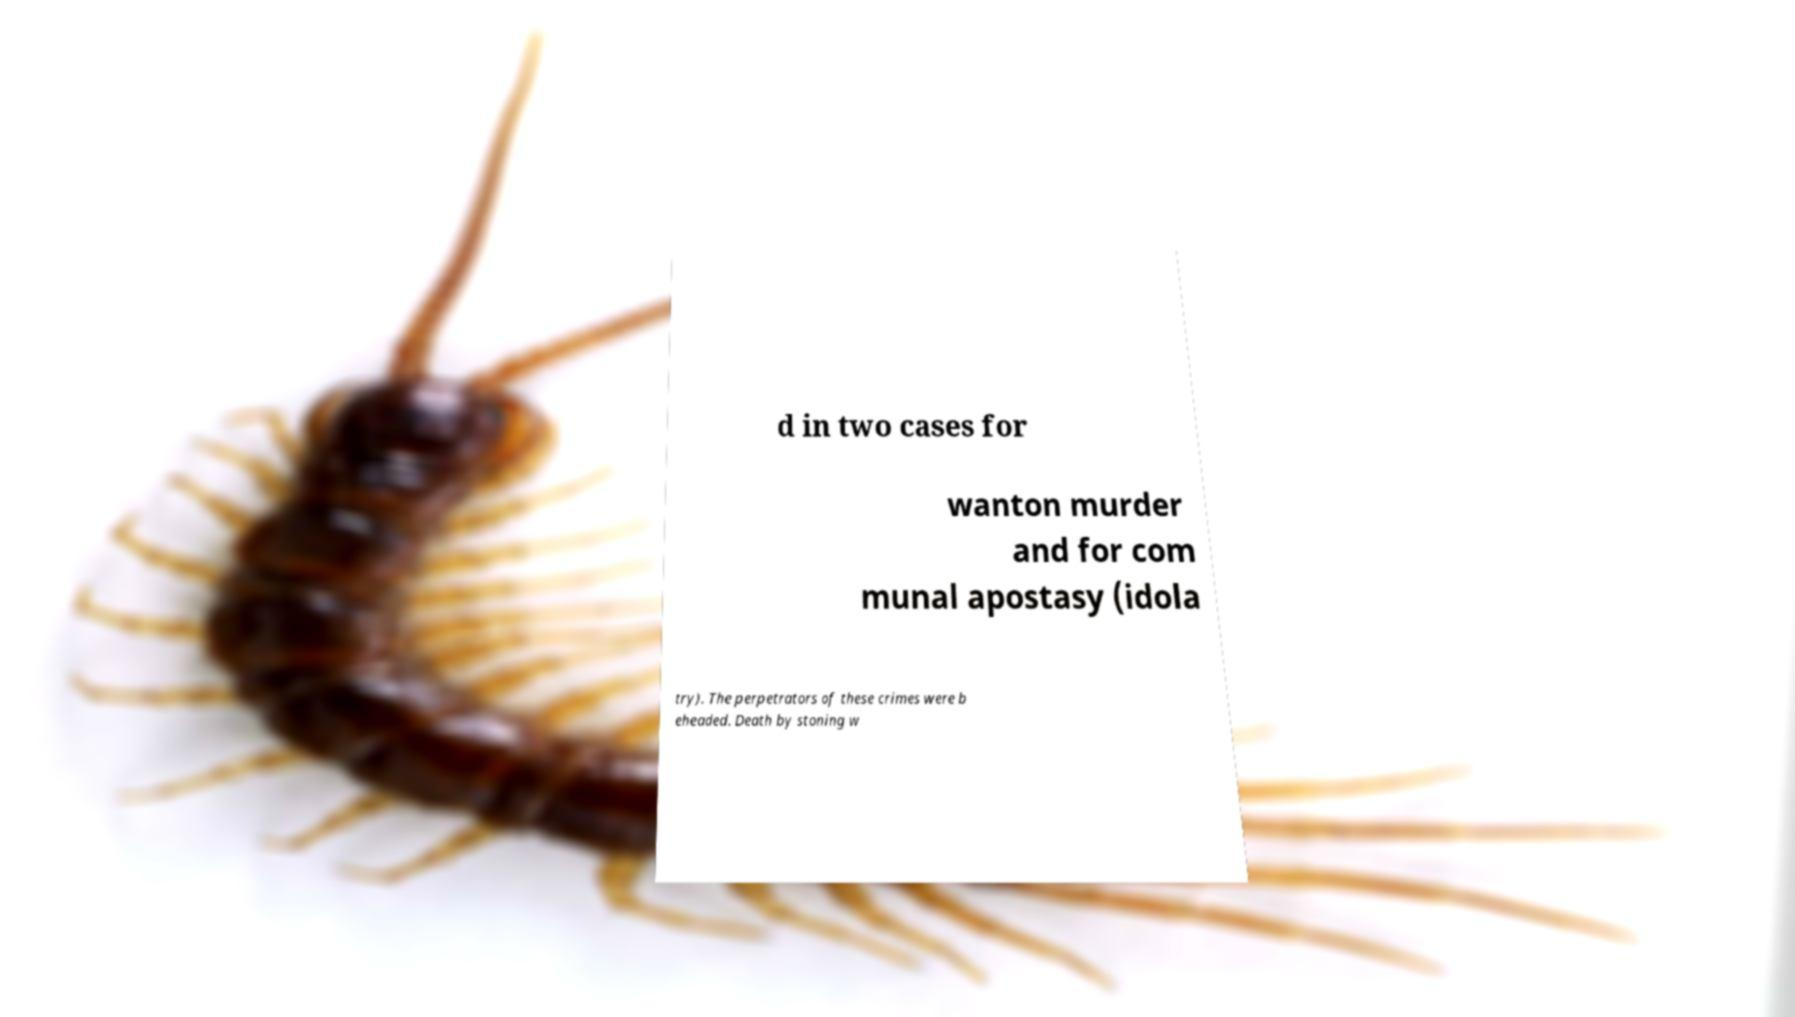There's text embedded in this image that I need extracted. Can you transcribe it verbatim? d in two cases for wanton murder and for com munal apostasy (idola try). The perpetrators of these crimes were b eheaded. Death by stoning w 